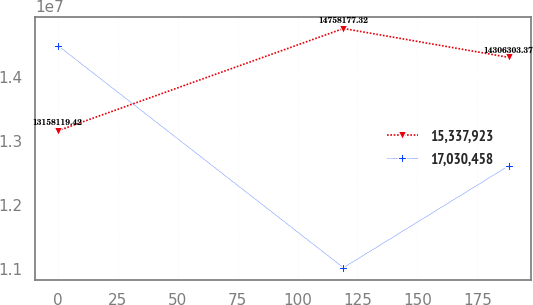<chart> <loc_0><loc_0><loc_500><loc_500><line_chart><ecel><fcel>15,337,923<fcel>17,030,458<nl><fcel>0<fcel>1.31581e+07<fcel>1.4491e+07<nl><fcel>119.15<fcel>1.47582e+07<fcel>1.10142e+07<nl><fcel>188.12<fcel>1.43063e+07<fcel>1.26095e+07<nl></chart> 